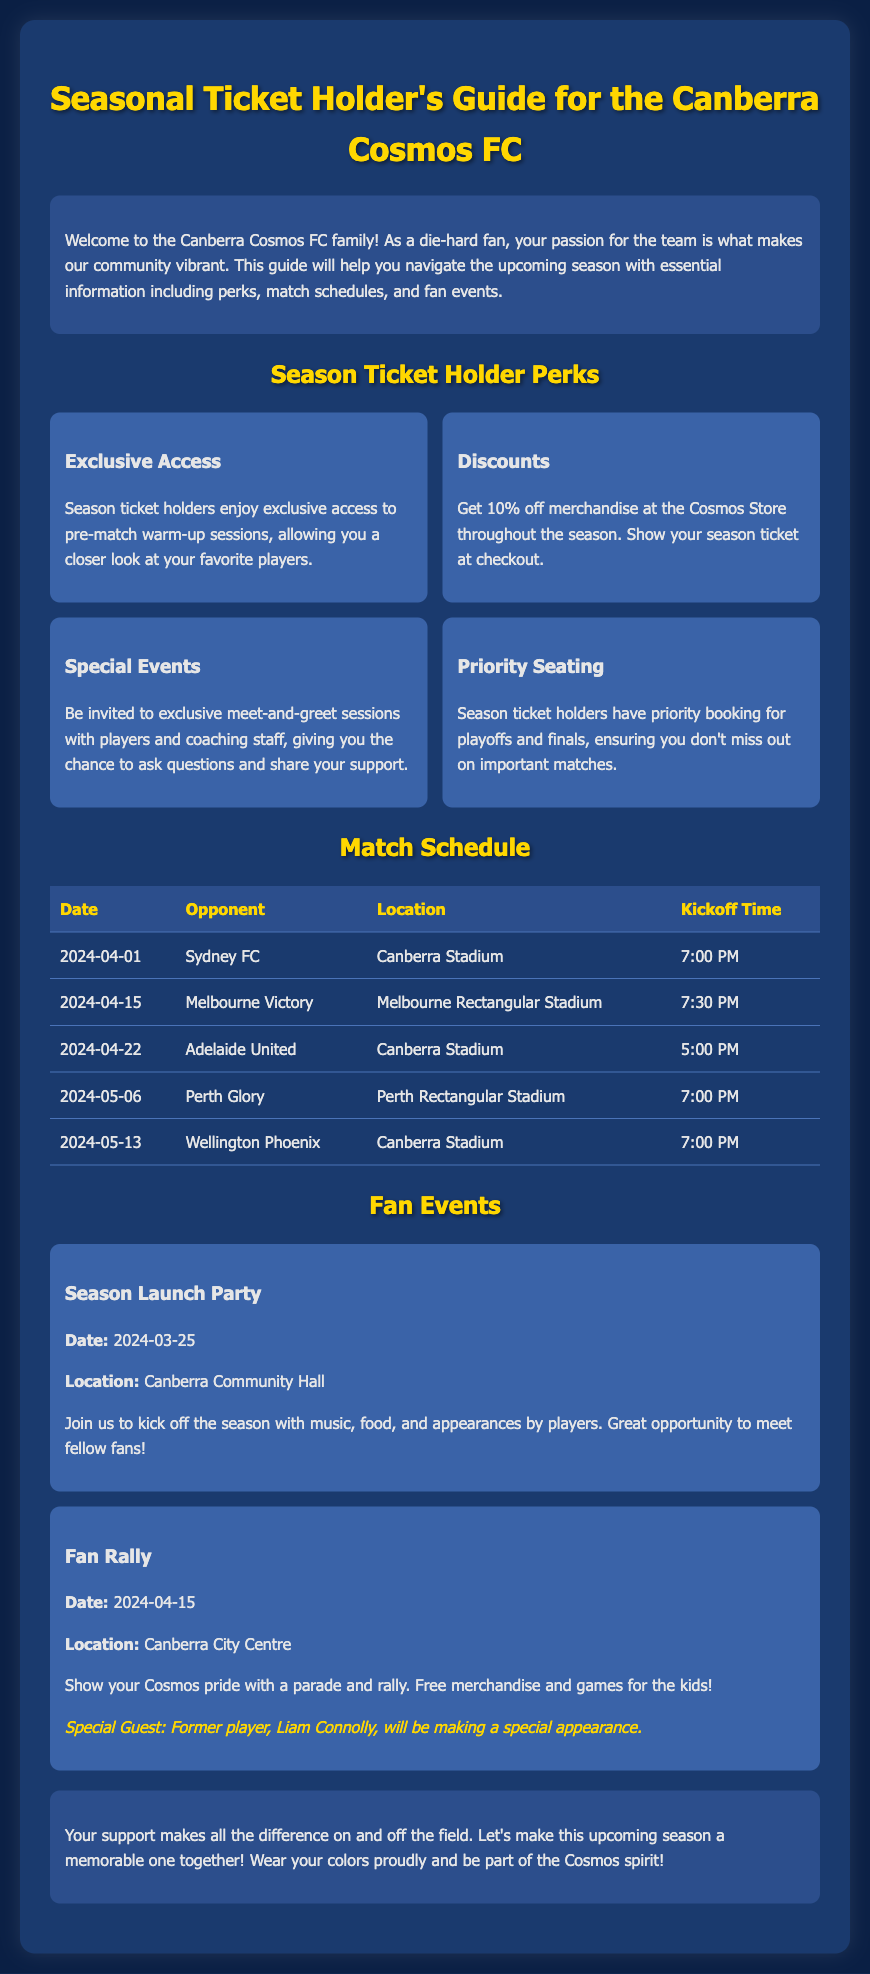What is the first match date? The first match date listed in the schedule is April 1, 2024, where they play against Sydney FC.
Answer: April 1, 2024 How much discount do season ticket holders receive at the Cosmos Store? The document states that season ticket holders receive a 10% discount on merchandise at the store.
Answer: 10% Who is the special guest at the Fan Rally? The document mentions that the special guest at the Fan Rally is former player Liam Connolly.
Answer: Liam Connolly Where will the Season Launch Party be held? The location for the Season Launch Party is specified as the Canberra Community Hall.
Answer: Canberra Community Hall What time does the match against Adelaide United start? According to the match schedule, the game against Adelaide United starts at 5:00 PM.
Answer: 5:00 PM What is one of the perks of being a season ticket holder? One of the perks mentioned is the exclusive access to pre-match warm-up sessions.
Answer: Exclusive Access How many matches are listed in the Match Schedule? There are five matches listed in the Match Schedule document.
Answer: Five What special activity is planned for the Season Launch Party? The document includes music, food, and player appearances as activities for the Season Launch Party.
Answer: Music, food, and player appearances What date is the Fan Rally scheduled for? The Fan Rally is scheduled for April 15, 2024.
Answer: April 15, 2024 